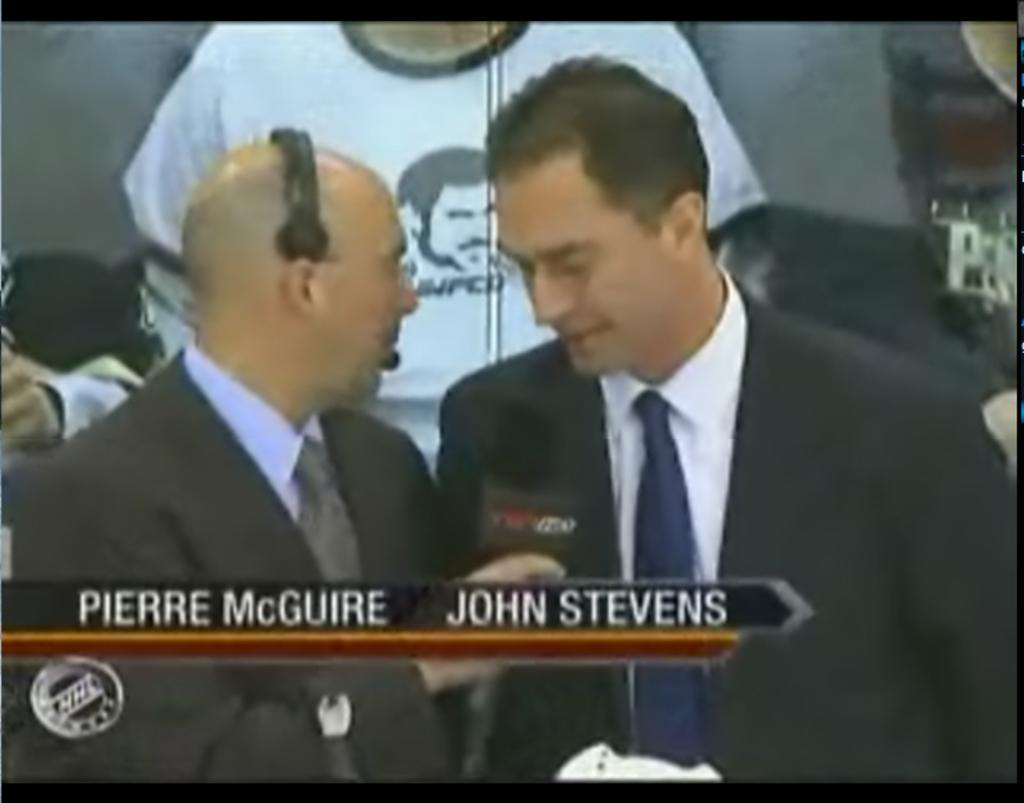How many people are in the image? There are two men in the image. What are the men wearing? The men are wearing suits. What can be seen in the background of the image? There is a poster in the background of the image. What type of brass instrument is the man playing in the image? There is no brass instrument or music being played in the image; the men are simply standing and wearing suits. 